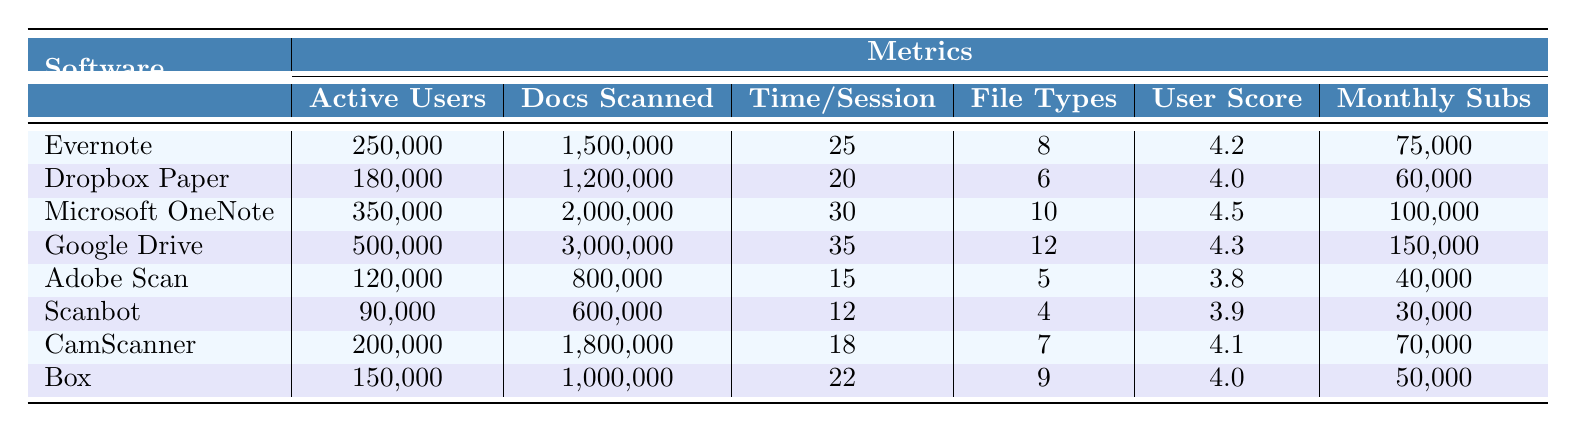What is the software with the highest user satisfaction score? By examining the User Satisfaction Score column, I can identify Microsoft OneNote with a score of 4.5 as the highest.
Answer: Microsoft OneNote How many documents did Google Drive scan? In the table, the Documents Scanned column shows that Google Drive has scanned 3,000,000 documents.
Answer: 3,000,000 What is the difference in active users between Evernote and Adobe Scan? Evernote has 250,000 active users while Adobe Scan has 120,000. The difference is calculated by subtracting: 250,000 - 120,000 = 130,000.
Answer: 130,000 Is the average time spent per session for Dropbox Paper and CamScanner greater than 20 minutes? For Dropbox Paper, the Time Spent Per Session is 20 minutes, and for CamScanner, it is 18 minutes. The average is (20 + 18) / 2 = 19, which is less than 20.
Answer: No Which software has the lowest number of documents scanned in the table? The Documents Scanned column reveals that Scanbot has scanned 600,000 documents, which is the lowest count when compared to all other software.
Answer: Scanbot What is the total number of active users across all the software listed in the table? Adding the active users together: 250,000 + 180,000 + 350,000 + 500,000 + 120,000 + 90,000 + 200,000 + 150,000 gives a total of 1,840,000 active users.
Answer: 1,840,000 Are there more monthly subscriptions for Google Drive than for Microsoft OneNote? Google Drive has 150,000 monthly subscriptions while Microsoft OneNote has 100,000. Since 150,000 is greater than 100,000, the answer is yes.
Answer: Yes What is the average user satisfaction score for the software tools presented? The scores are 4.2, 4.0, 4.5, 4.3, 3.8, 3.9, 4.1, and 4.0, totaling 33.8. Calculating the average: 33.8 / 8 = 4.225, rounding to two decimal places gives approximately 4.23.
Answer: 4.23 Which software has the highest number of file types supported? Looking at the File Types Supported column, Google Drive has the highest count with 12 file types supported.
Answer: Google Drive What is the total number of documents scanned by the software based in North America? Summing the documents scanned for Evernote (1,500,000) and CamScanner (1,800,000) gives 1,500,000 + 1,800,000 = 3,300,000 documents scanned in total.
Answer: 3,300,000 